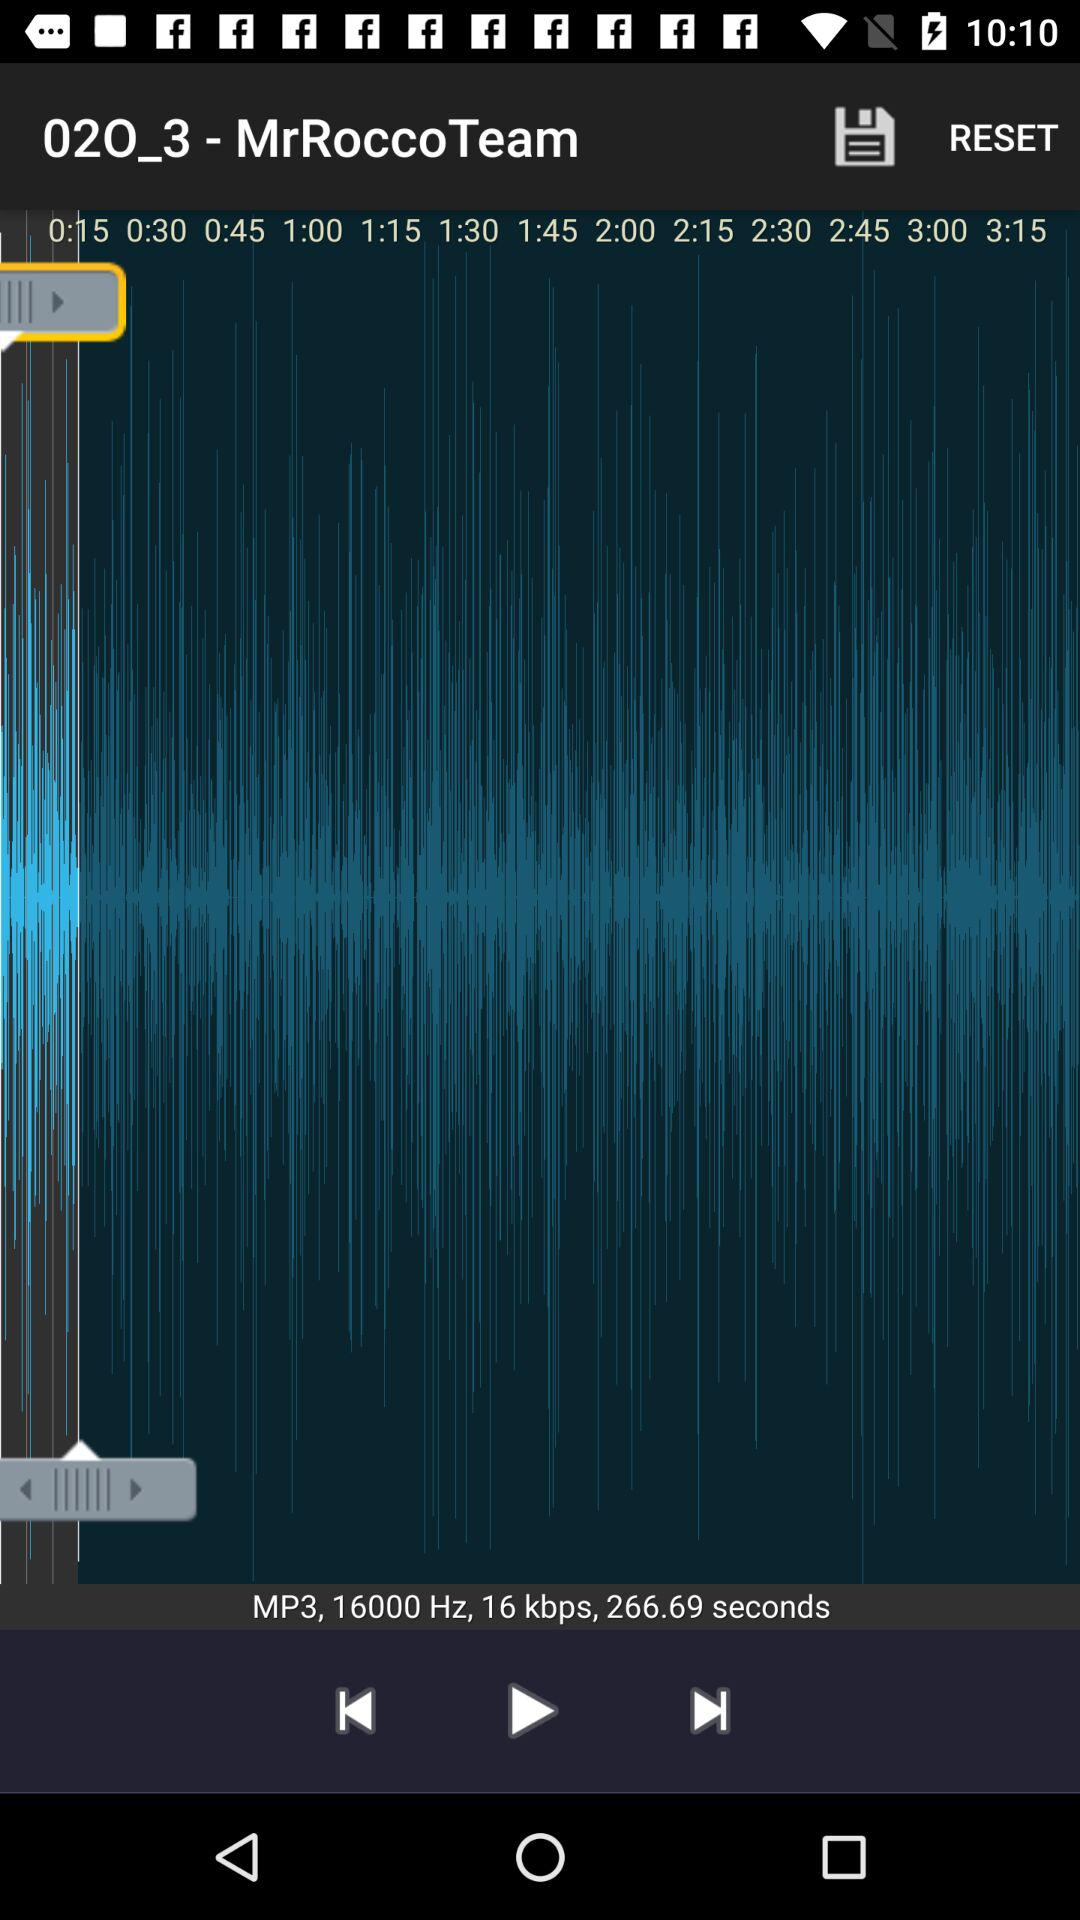What is the format of the audio? The format of the audio is MP3. 